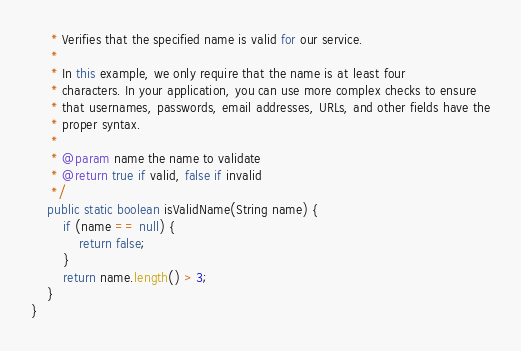Convert code to text. <code><loc_0><loc_0><loc_500><loc_500><_Java_>     * Verifies that the specified name is valid for our service.
     * 
     * In this example, we only require that the name is at least four
     * characters. In your application, you can use more complex checks to ensure
     * that usernames, passwords, email addresses, URLs, and other fields have the
     * proper syntax.
     * 
     * @param name the name to validate
     * @return true if valid, false if invalid
     */
    public static boolean isValidName(String name) {
        if (name == null) {
            return false;
        }
        return name.length() > 3;
    }
}
</code> 